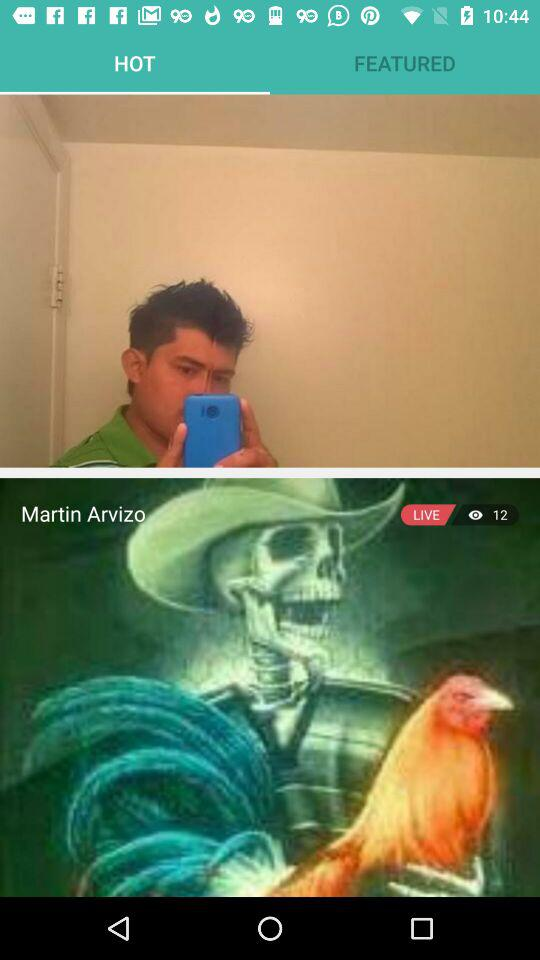How many viewers are watching the live stream by Martin Arvizo? The number of viewers watching the live stream by Martin Arvizo is 12. 